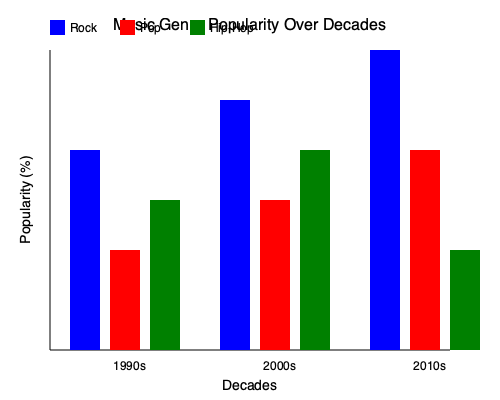As a music producer with experience across decades, how would you describe the trend in rock music popularity from the 1990s to the 2010s, and what potential factors might have contributed to this trend? To answer this question, let's analyze the graph step-by-step:

1. Identify the rock music trend:
   - 1990s: Rock popularity is at about 60%
   - 2000s: Rock popularity increases to about 75%
   - 2010s: Rock popularity reaches its peak at about 90%

2. Describe the trend:
   The trend shows a steady increase in rock music popularity across the three decades.

3. Potential factors contributing to this trend:
   a) Evolution of rock subgenres: The emergence of new rock subgenres (e.g., grunge in the 90s, indie rock in the 2000s) might have attracted new audiences.
   b) Nostalgia factor: As the original rock fans aged, they might have influenced younger generations to appreciate rock music.
   c) Technological advancements: Improved recording techniques and the rise of digital platforms may have made rock music more accessible.
   d) Cultural shifts: Rock music might have aligned well with changing societal values and attitudes over these decades.
   e) Crossover appeal: Collaboration between rock artists and artists from other genres could have expanded rock's audience.

4. Connection to the persona:
   As a music producer and sibling of a retired rock star, you would have firsthand experience with these trends and factors. Your involvement in charitable endeavors might also have exposed you to how rock music's popularity influenced its use in fundraising and awareness campaigns.
Answer: Steady increase in rock popularity due to genre evolution, nostalgia, technology, cultural shifts, and crossover appeal. 